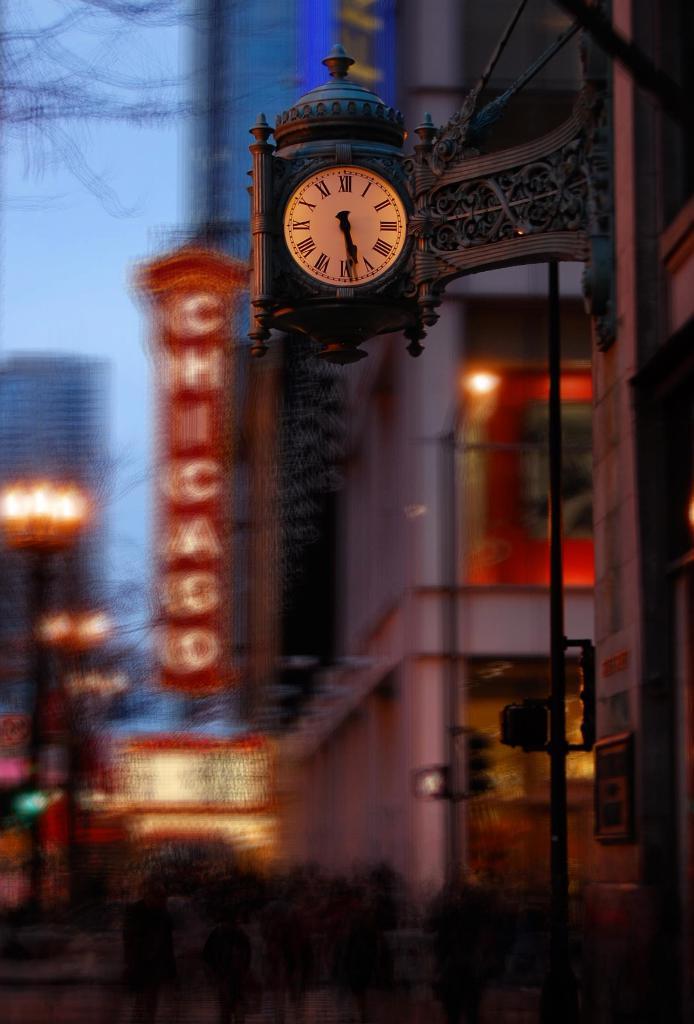What time does the clock say?
Your answer should be compact. 5:29. What city name is shown in the back?
Keep it short and to the point. Chicago. 